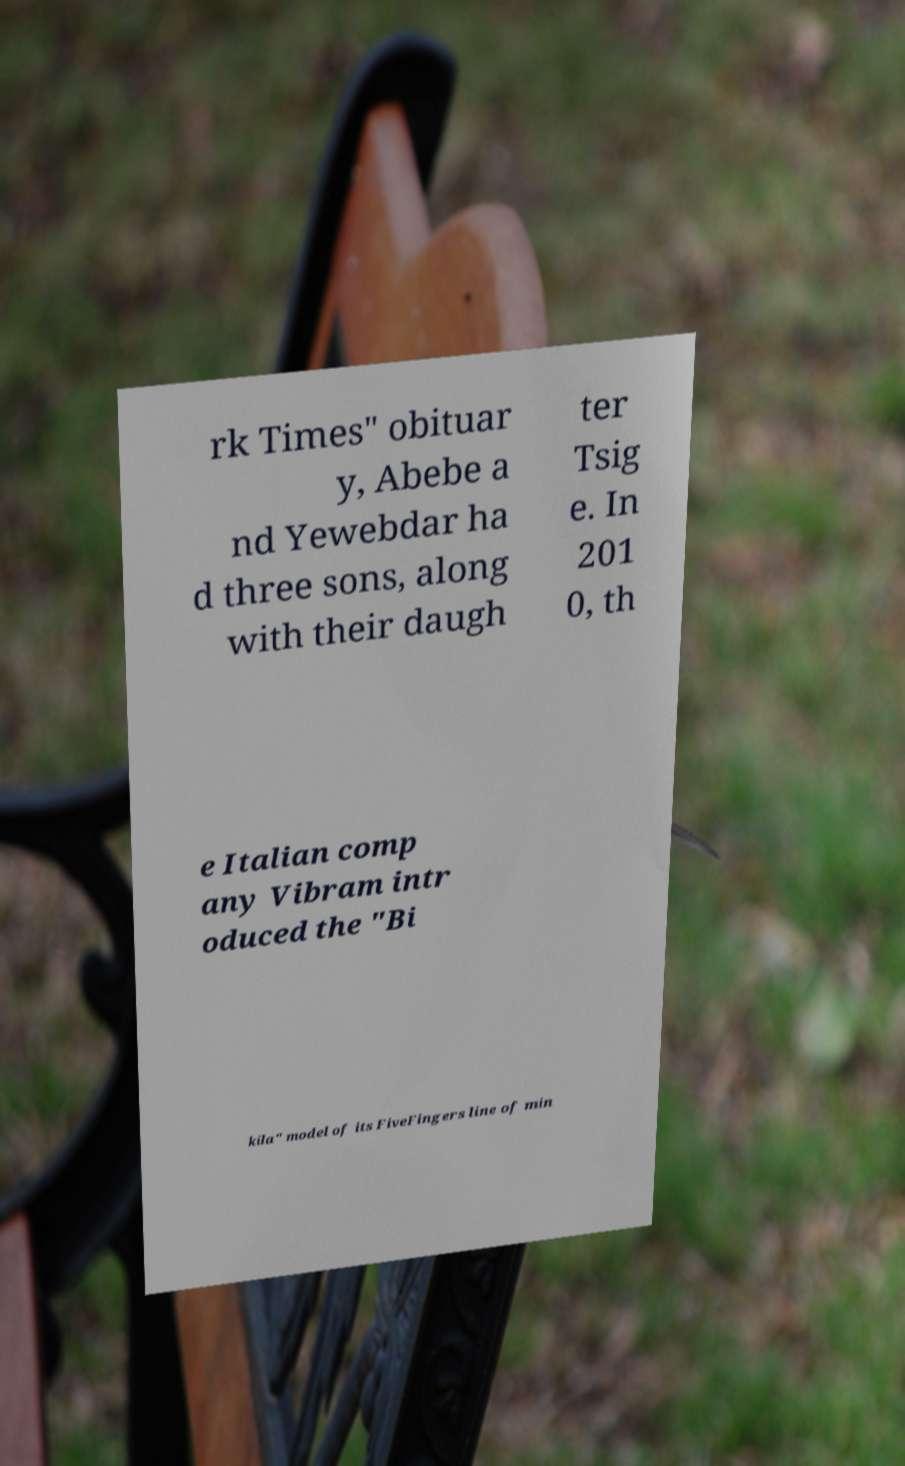There's text embedded in this image that I need extracted. Can you transcribe it verbatim? rk Times" obituar y, Abebe a nd Yewebdar ha d three sons, along with their daugh ter Tsig e. In 201 0, th e Italian comp any Vibram intr oduced the "Bi kila" model of its FiveFingers line of min 